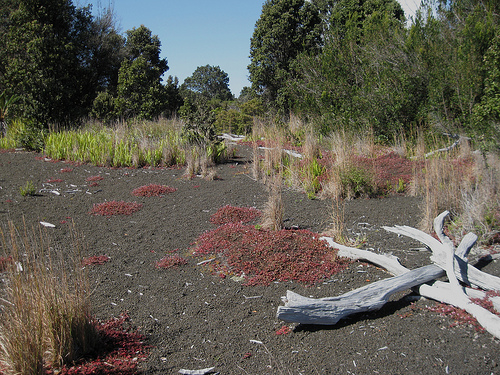<image>
Can you confirm if the log is on the dirt? Yes. Looking at the image, I can see the log is positioned on top of the dirt, with the dirt providing support. 